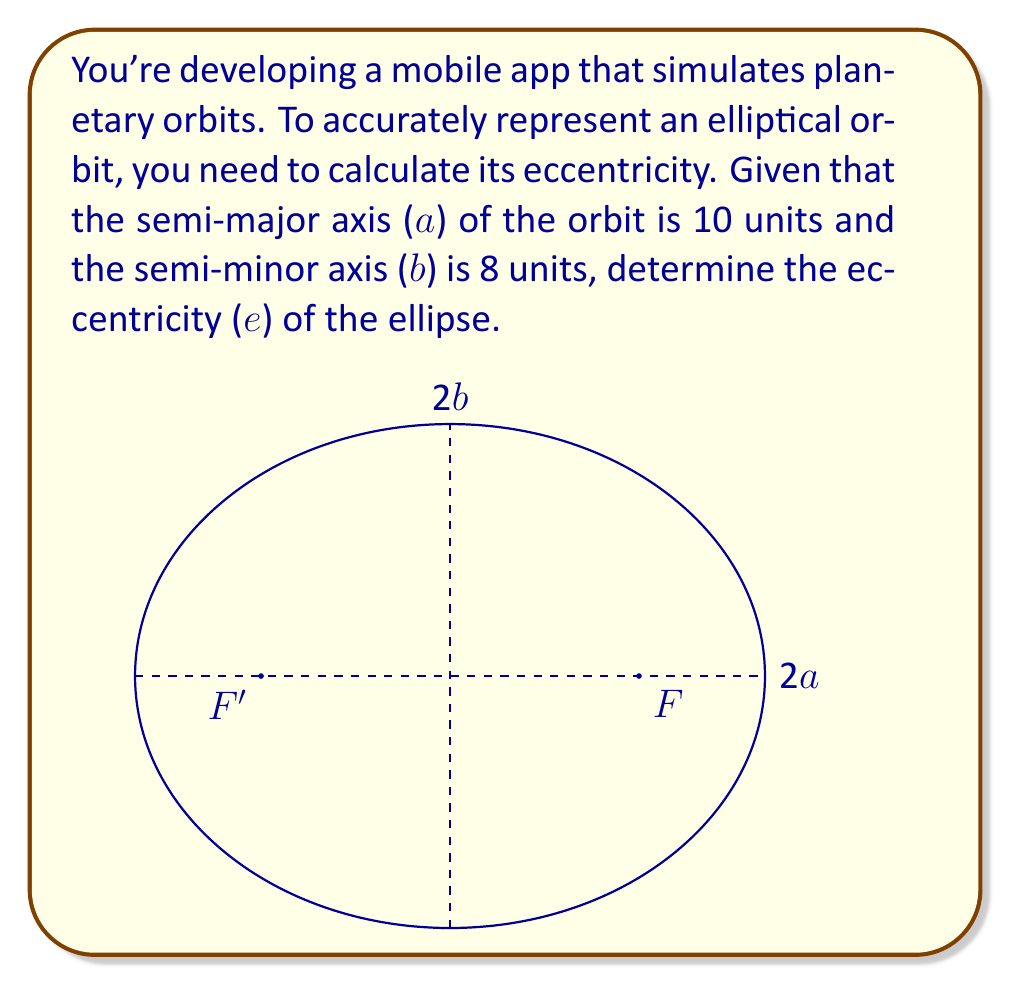Teach me how to tackle this problem. To find the eccentricity of an ellipse using its semi-major (a) and semi-minor (b) axes, we can follow these steps:

1) The eccentricity (e) of an ellipse is defined as the ratio of the distance between the foci to the length of the major axis. It can be calculated using the formula:

   $$e = \sqrt{1 - \frac{b^2}{a^2}}$$

2) We are given:
   Semi-major axis, $a = 10$ units
   Semi-minor axis, $b = 8$ units

3) Let's substitute these values into the formula:

   $$e = \sqrt{1 - \frac{8^2}{10^2}}$$

4) Simplify inside the parentheses:

   $$e = \sqrt{1 - \frac{64}{100}}$$

5) Perform the division:

   $$e = \sqrt{1 - 0.64}$$

6) Subtract:

   $$e = \sqrt{0.36}$$

7) Calculate the square root:

   $$e = 0.6$$

Therefore, the eccentricity of the ellipse is 0.6.
Answer: $e = 0.6$ 